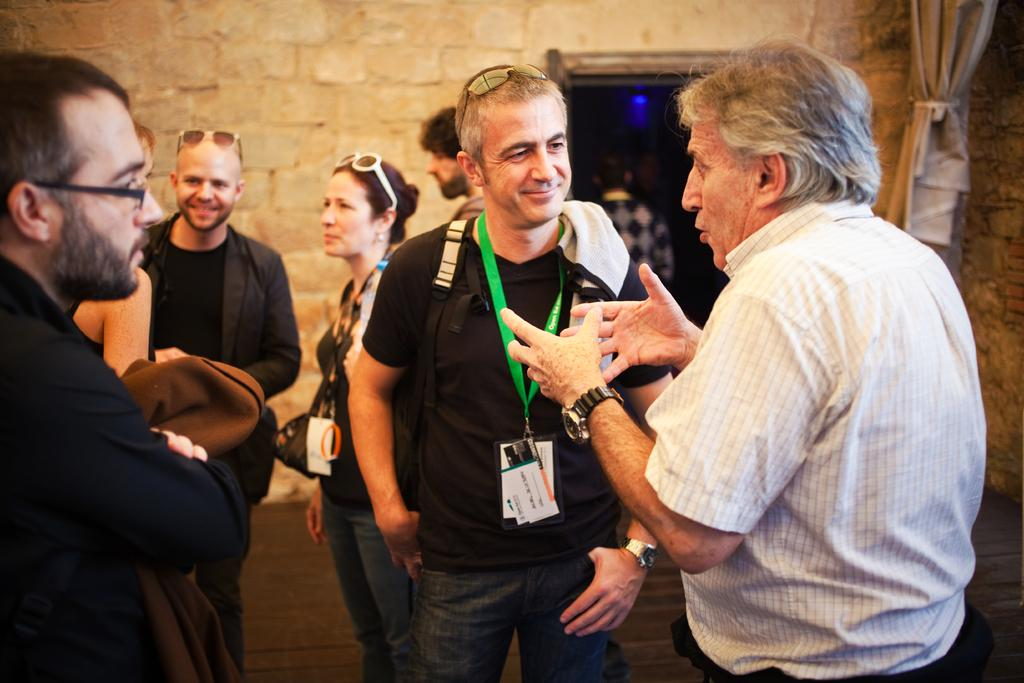What is happening with the group of people in the image? The people in the image are holding ID cards and talking to each other. Where are the people standing in the image? The people are standing on the ground in the image. What can be seen in the background of the image? There is a stone wall and a door with a curtain in the background of the image. What type of skirt is the partner wearing in the image? There is no partner or skirt present in the image. How many fingers can be seen on the person's hand in the image? The image does not show any fingers or hands, so it is not possible to determine the number of fingers. 